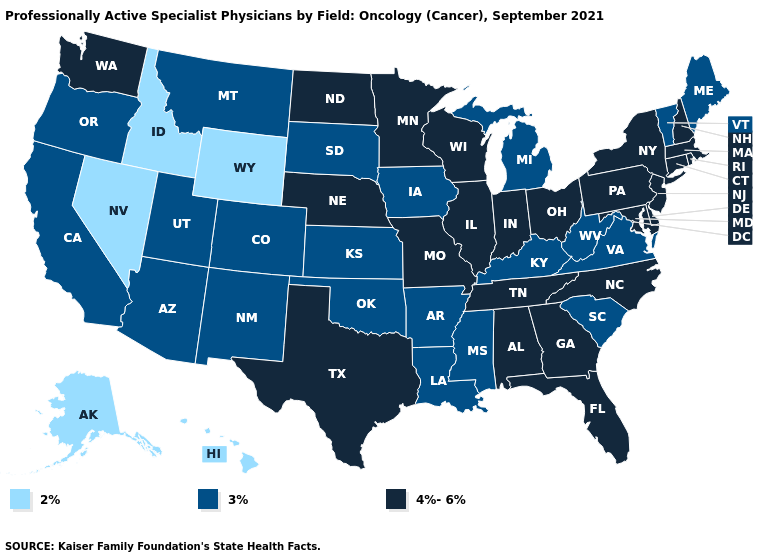How many symbols are there in the legend?
Write a very short answer. 3. Does Mississippi have the highest value in the USA?
Quick response, please. No. Does the map have missing data?
Write a very short answer. No. What is the value of Colorado?
Give a very brief answer. 3%. What is the value of Rhode Island?
Keep it brief. 4%-6%. Does the first symbol in the legend represent the smallest category?
Short answer required. Yes. Does Connecticut have the highest value in the USA?
Short answer required. Yes. Which states have the highest value in the USA?
Keep it brief. Alabama, Connecticut, Delaware, Florida, Georgia, Illinois, Indiana, Maryland, Massachusetts, Minnesota, Missouri, Nebraska, New Hampshire, New Jersey, New York, North Carolina, North Dakota, Ohio, Pennsylvania, Rhode Island, Tennessee, Texas, Washington, Wisconsin. Does the map have missing data?
Be succinct. No. Among the states that border North Dakota , which have the lowest value?
Give a very brief answer. Montana, South Dakota. What is the lowest value in states that border New Mexico?
Answer briefly. 3%. What is the value of Montana?
Short answer required. 3%. Among the states that border Oklahoma , which have the lowest value?
Answer briefly. Arkansas, Colorado, Kansas, New Mexico. Which states have the lowest value in the USA?
Write a very short answer. Alaska, Hawaii, Idaho, Nevada, Wyoming. Which states have the highest value in the USA?
Quick response, please. Alabama, Connecticut, Delaware, Florida, Georgia, Illinois, Indiana, Maryland, Massachusetts, Minnesota, Missouri, Nebraska, New Hampshire, New Jersey, New York, North Carolina, North Dakota, Ohio, Pennsylvania, Rhode Island, Tennessee, Texas, Washington, Wisconsin. 